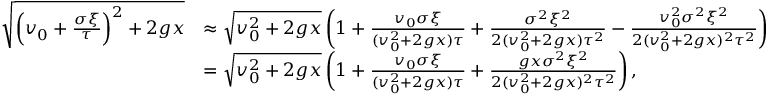<formula> <loc_0><loc_0><loc_500><loc_500>\begin{array} { r l } { \sqrt { \left ( v _ { 0 } + \frac { \sigma \xi } { \tau } \right ) ^ { 2 } + 2 g x } } & { \approx \sqrt { v _ { 0 } ^ { 2 } + 2 g x } \left ( 1 + \frac { v _ { 0 } \sigma \xi } { ( v _ { 0 } ^ { 2 } + 2 g x ) \tau } + \frac { \sigma ^ { 2 } \xi ^ { 2 } } { 2 ( v _ { 0 } ^ { 2 } + 2 g x ) \tau ^ { 2 } } - \frac { v _ { 0 } ^ { 2 } \sigma ^ { 2 } \xi ^ { 2 } } { 2 ( v _ { 0 } ^ { 2 } + 2 g x ) ^ { 2 } \tau ^ { 2 } } \right ) } \\ & { = \sqrt { v _ { 0 } ^ { 2 } + 2 g x } \left ( 1 + \frac { v _ { 0 } \sigma \xi } { ( v _ { 0 } ^ { 2 } + 2 g x ) \tau } + \frac { g x \sigma ^ { 2 } \xi ^ { 2 } } { 2 ( v _ { 0 } ^ { 2 } + 2 g x ) ^ { 2 } \tau ^ { 2 } } \right ) , } \end{array}</formula> 